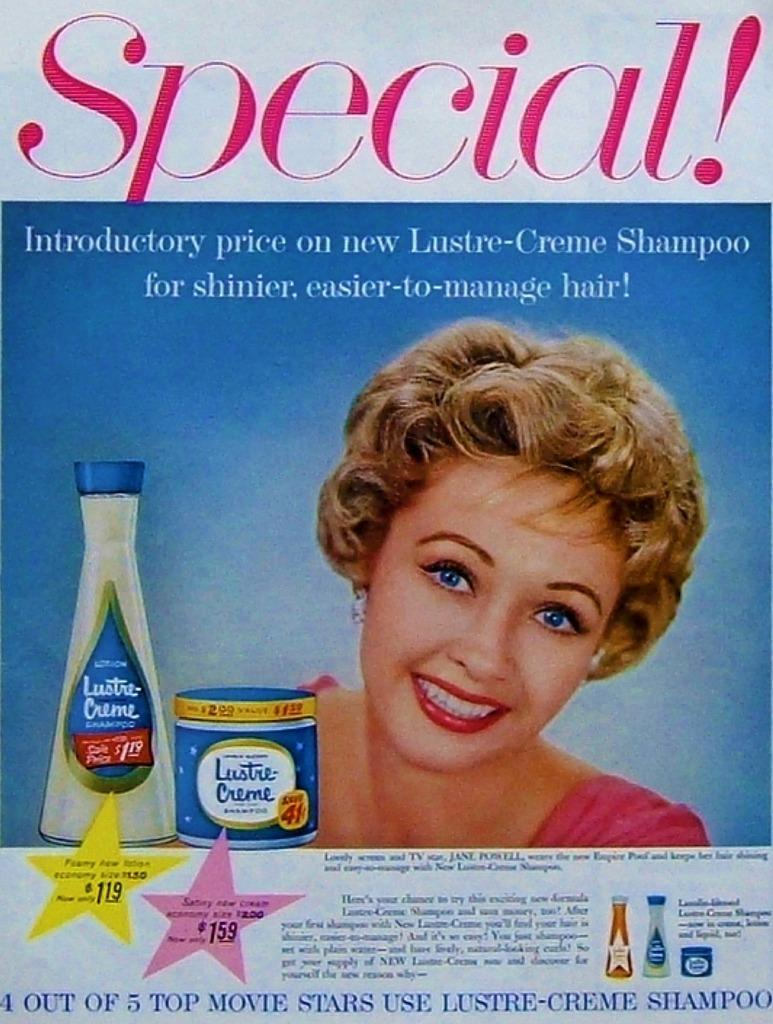<image>
Write a terse but informative summary of the picture. A color advertisement for Lustre Creme shampoo at an introductory price. 